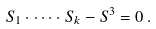Convert formula to latex. <formula><loc_0><loc_0><loc_500><loc_500>S _ { 1 } \cdot \dots \cdot S _ { k } - S ^ { 3 } = 0 \, .</formula> 